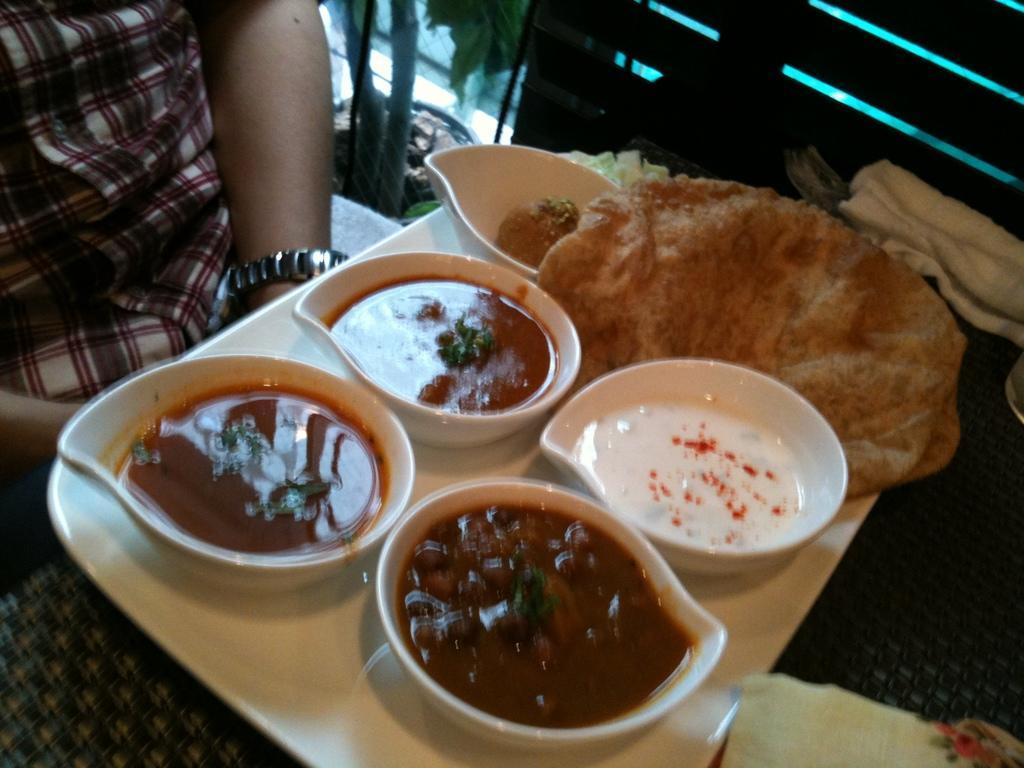Could you give a brief overview of what you see in this image? In this image I can see there is some food placed on the plate and there is a person sitting at the left side. There is a planet visible from the glass door. 